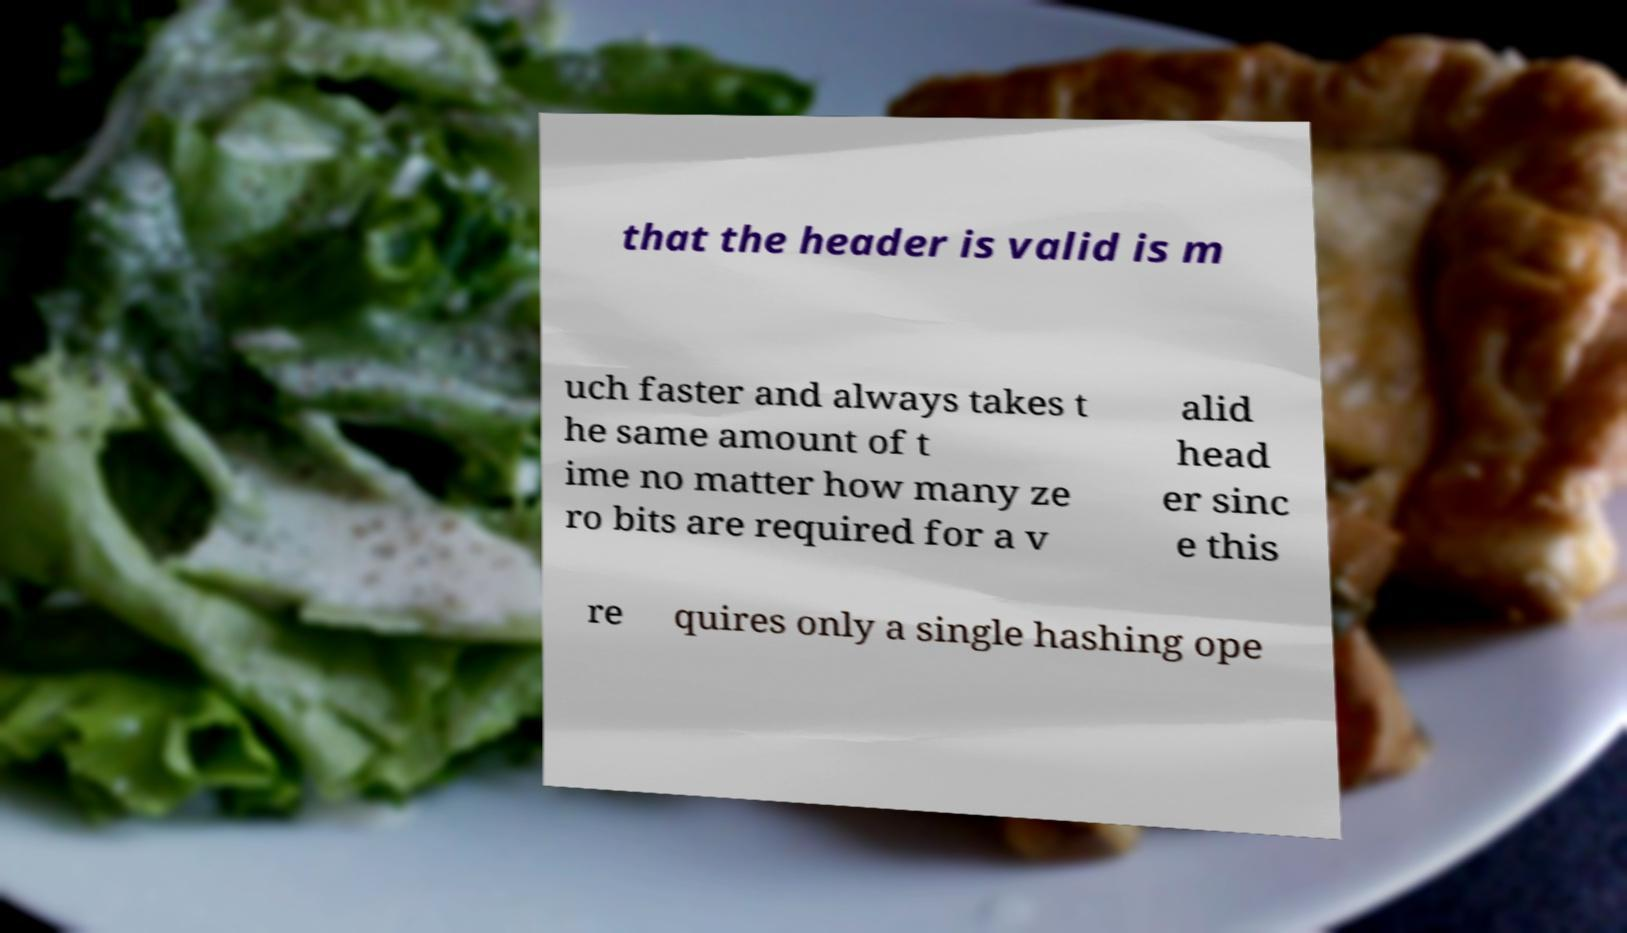Please read and relay the text visible in this image. What does it say? that the header is valid is m uch faster and always takes t he same amount of t ime no matter how many ze ro bits are required for a v alid head er sinc e this re quires only a single hashing ope 